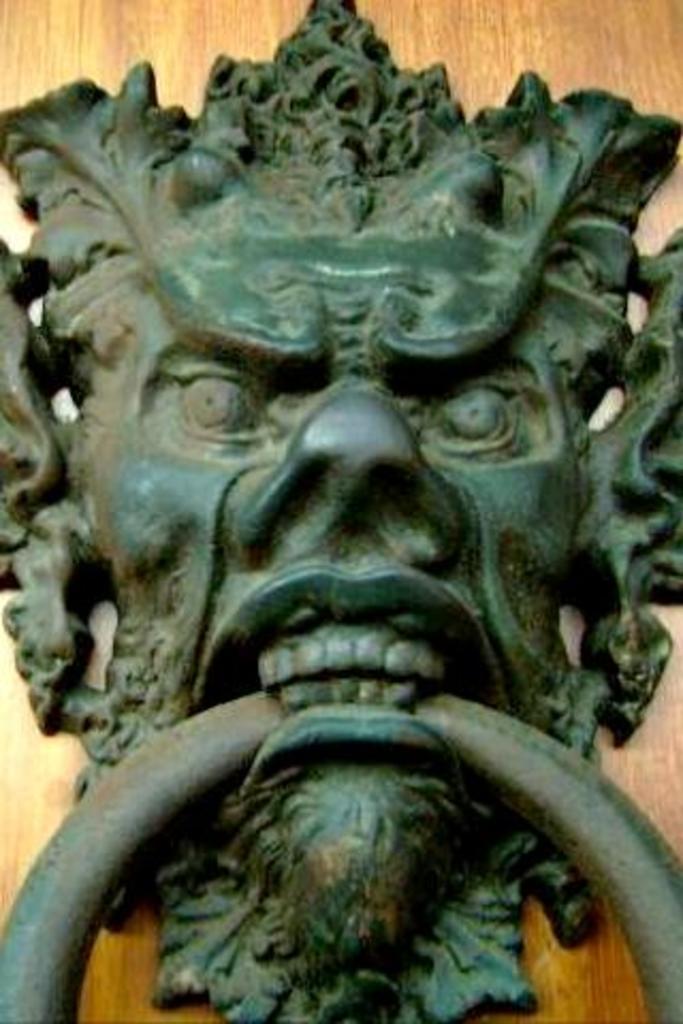Please provide a concise description of this image. In this image I can see a door knocker attached to a wooden object. 